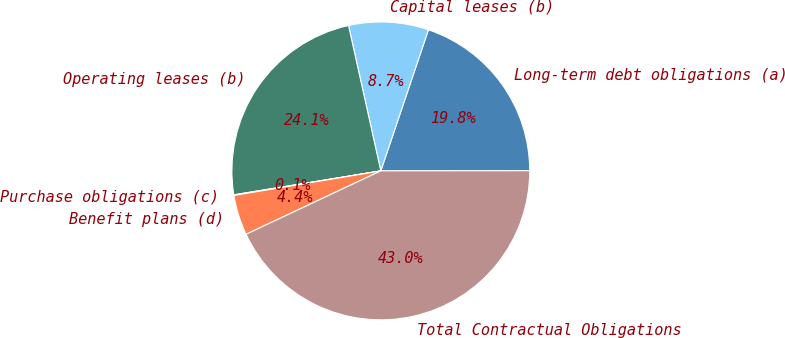Convert chart. <chart><loc_0><loc_0><loc_500><loc_500><pie_chart><fcel>Long-term debt obligations (a)<fcel>Capital leases (b)<fcel>Operating leases (b)<fcel>Purchase obligations (c)<fcel>Benefit plans (d)<fcel>Total Contractual Obligations<nl><fcel>19.8%<fcel>8.66%<fcel>24.09%<fcel>0.07%<fcel>4.36%<fcel>43.02%<nl></chart> 